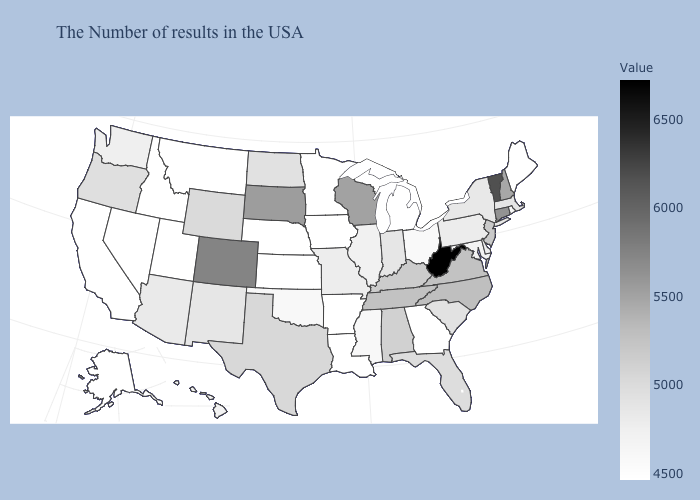Which states hav the highest value in the South?
Write a very short answer. West Virginia. Which states have the lowest value in the USA?
Write a very short answer. Maine, Georgia, Michigan, Louisiana, Arkansas, Minnesota, Iowa, Kansas, Nebraska, Montana, Idaho, Nevada, California, Alaska. Does New Hampshire have a lower value than Colorado?
Concise answer only. Yes. Which states have the lowest value in the MidWest?
Give a very brief answer. Michigan, Minnesota, Iowa, Kansas, Nebraska. Among the states that border Wisconsin , does Michigan have the lowest value?
Answer briefly. Yes. 